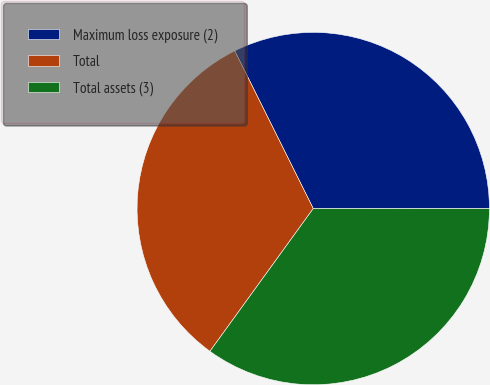Convert chart to OTSL. <chart><loc_0><loc_0><loc_500><loc_500><pie_chart><fcel>Maximum loss exposure (2)<fcel>Total<fcel>Total assets (3)<nl><fcel>32.37%<fcel>32.68%<fcel>34.96%<nl></chart> 